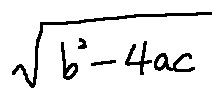Convert formula to latex. <formula><loc_0><loc_0><loc_500><loc_500>\sqrt { b ^ { 2 } - 4 a c }</formula> 